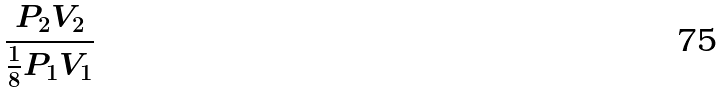<formula> <loc_0><loc_0><loc_500><loc_500>\frac { P _ { 2 } V _ { 2 } } { \frac { 1 } { 8 } P _ { 1 } V _ { 1 } }</formula> 